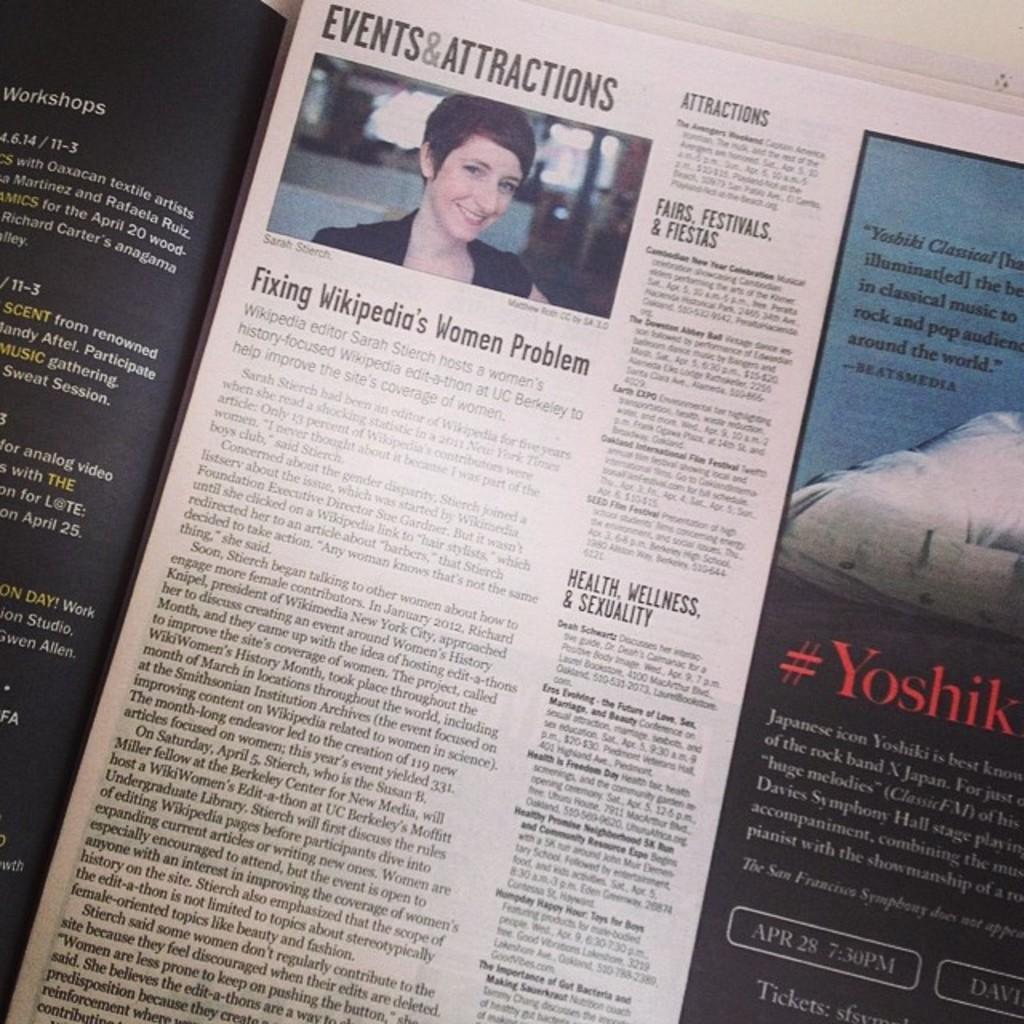Describe this image in one or two sentences. In this image, we can see a newspaper and there is an image of a lady and we can see text. 